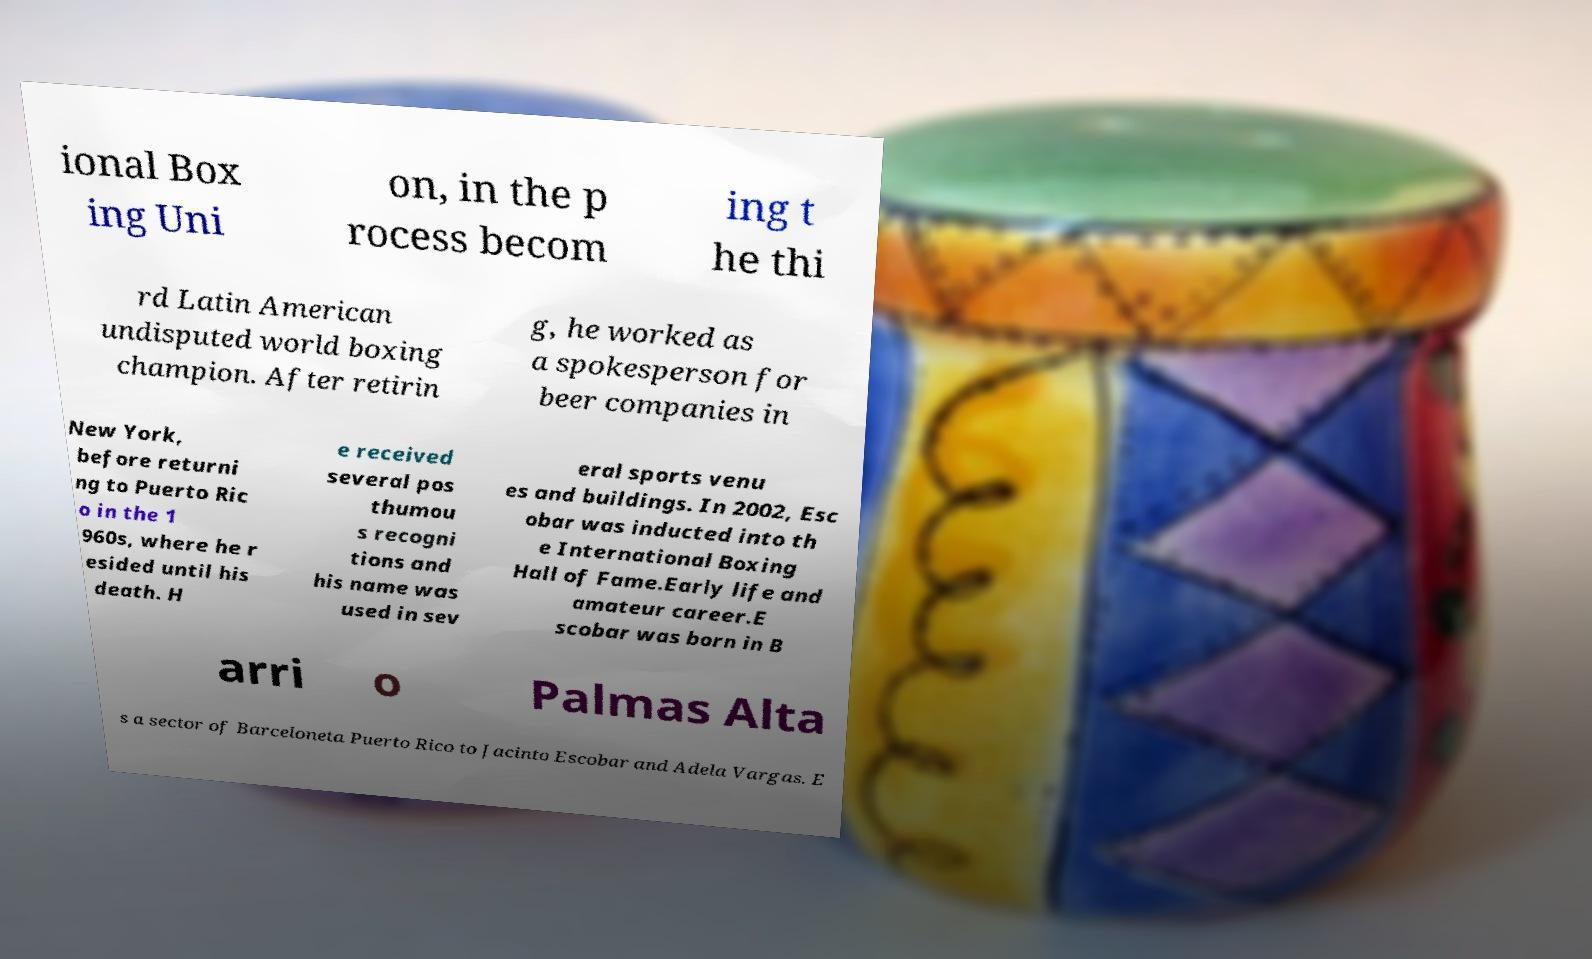Can you accurately transcribe the text from the provided image for me? ional Box ing Uni on, in the p rocess becom ing t he thi rd Latin American undisputed world boxing champion. After retirin g, he worked as a spokesperson for beer companies in New York, before returni ng to Puerto Ric o in the 1 960s, where he r esided until his death. H e received several pos thumou s recogni tions and his name was used in sev eral sports venu es and buildings. In 2002, Esc obar was inducted into th e International Boxing Hall of Fame.Early life and amateur career.E scobar was born in B arri o Palmas Alta s a sector of Barceloneta Puerto Rico to Jacinto Escobar and Adela Vargas. E 